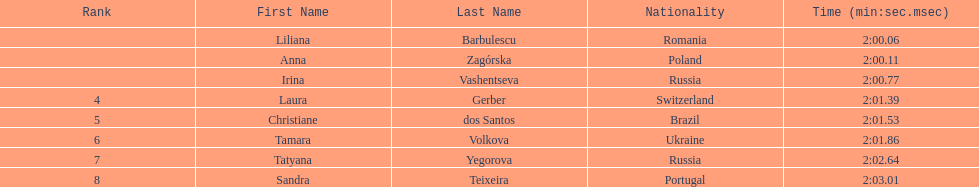Who came in second place at the athletics at the 2003 summer universiade - women's 800 metres? Anna Zagórska. What was her time? 2:00.11. 